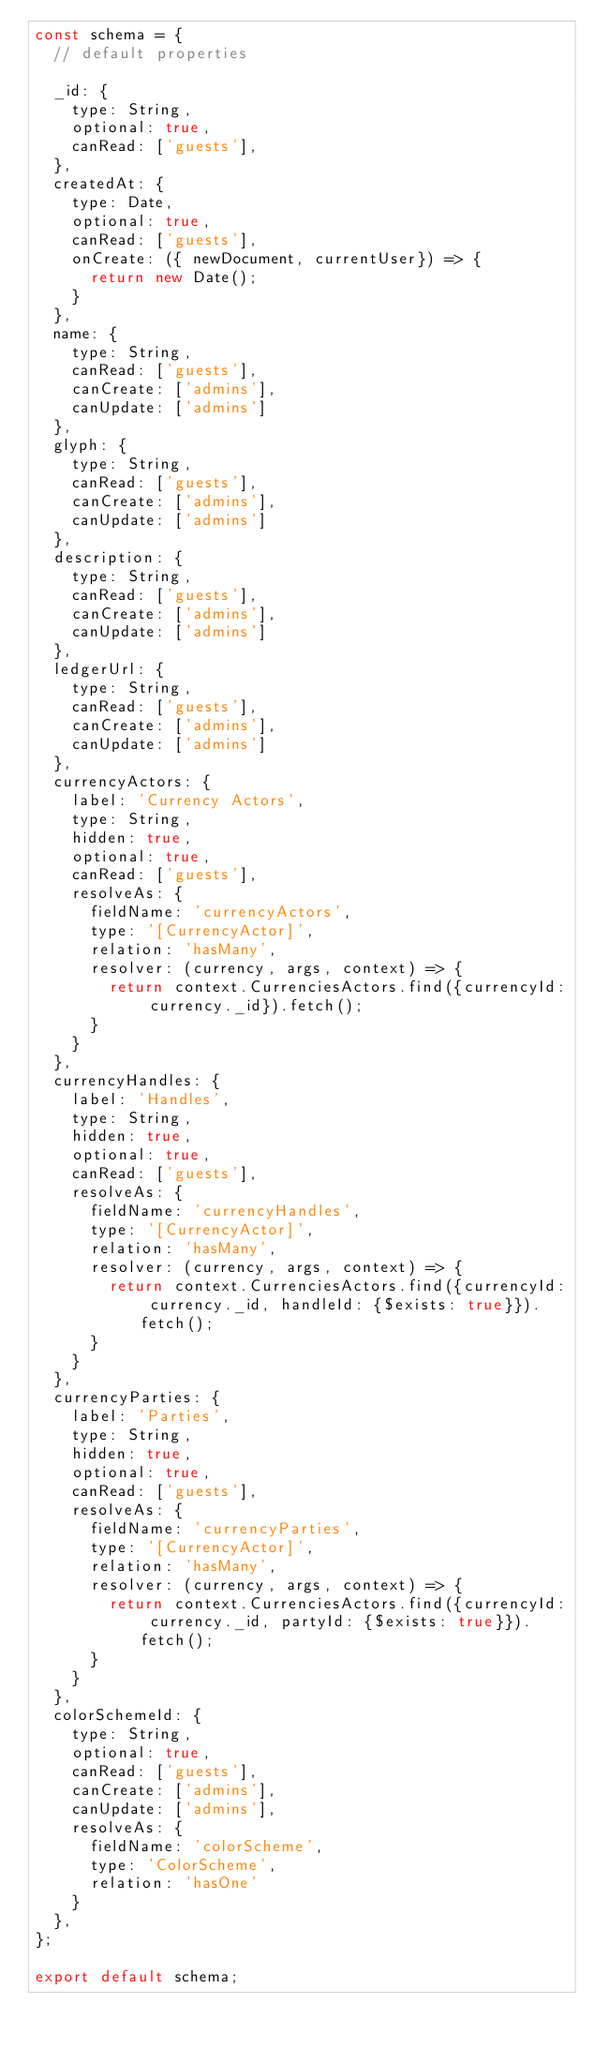Convert code to text. <code><loc_0><loc_0><loc_500><loc_500><_JavaScript_>const schema = {
  // default properties

  _id: {
    type: String,
    optional: true,
    canRead: ['guests'],
  },
  createdAt: {
    type: Date,
    optional: true,
    canRead: ['guests'],
    onCreate: ({ newDocument, currentUser}) => {
      return new Date();
    }
  },
  name: {
    type: String,
    canRead: ['guests'],
    canCreate: ['admins'],
    canUpdate: ['admins']
  },
  glyph: {
    type: String,
    canRead: ['guests'],
    canCreate: ['admins'],
    canUpdate: ['admins']
  },
  description: {
    type: String,
    canRead: ['guests'],
    canCreate: ['admins'],
    canUpdate: ['admins']
  },
  ledgerUrl: {
    type: String,
    canRead: ['guests'],
    canCreate: ['admins'],
    canUpdate: ['admins']
  },
  currencyActors: {
    label: 'Currency Actors',
    type: String,
    hidden: true,
    optional: true,
    canRead: ['guests'],
    resolveAs: {
      fieldName: 'currencyActors',
      type: '[CurrencyActor]',
      relation: 'hasMany',
      resolver: (currency, args, context) => {
        return context.CurrenciesActors.find({currencyId: currency._id}).fetch();
      }
    }
  },
  currencyHandles: {
    label: 'Handles',
    type: String,
    hidden: true,
    optional: true,
    canRead: ['guests'],
    resolveAs: {
      fieldName: 'currencyHandles',
      type: '[CurrencyActor]',
      relation: 'hasMany',
      resolver: (currency, args, context) => {
        return context.CurrenciesActors.find({currencyId: currency._id, handleId: {$exists: true}}).fetch();
      }
    }
  },
  currencyParties: {
    label: 'Parties',
    type: String,
    hidden: true,
    optional: true,
    canRead: ['guests'],
    resolveAs: {
      fieldName: 'currencyParties',
      type: '[CurrencyActor]',
      relation: 'hasMany',
      resolver: (currency, args, context) => {
        return context.CurrenciesActors.find({currencyId: currency._id, partyId: {$exists: true}}).fetch();
      }
    }
  },
  colorSchemeId: {
    type: String,
    optional: true,
    canRead: ['guests'],
    canCreate: ['admins'],
    canUpdate: ['admins'],
    resolveAs: {
      fieldName: 'colorScheme',
      type: 'ColorScheme',
      relation: 'hasOne'
    }
  },
};

export default schema;
</code> 